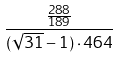Convert formula to latex. <formula><loc_0><loc_0><loc_500><loc_500>\frac { \frac { 2 8 8 } { 1 8 9 } } { ( \sqrt { 3 1 } - 1 ) \cdot 4 6 4 }</formula> 